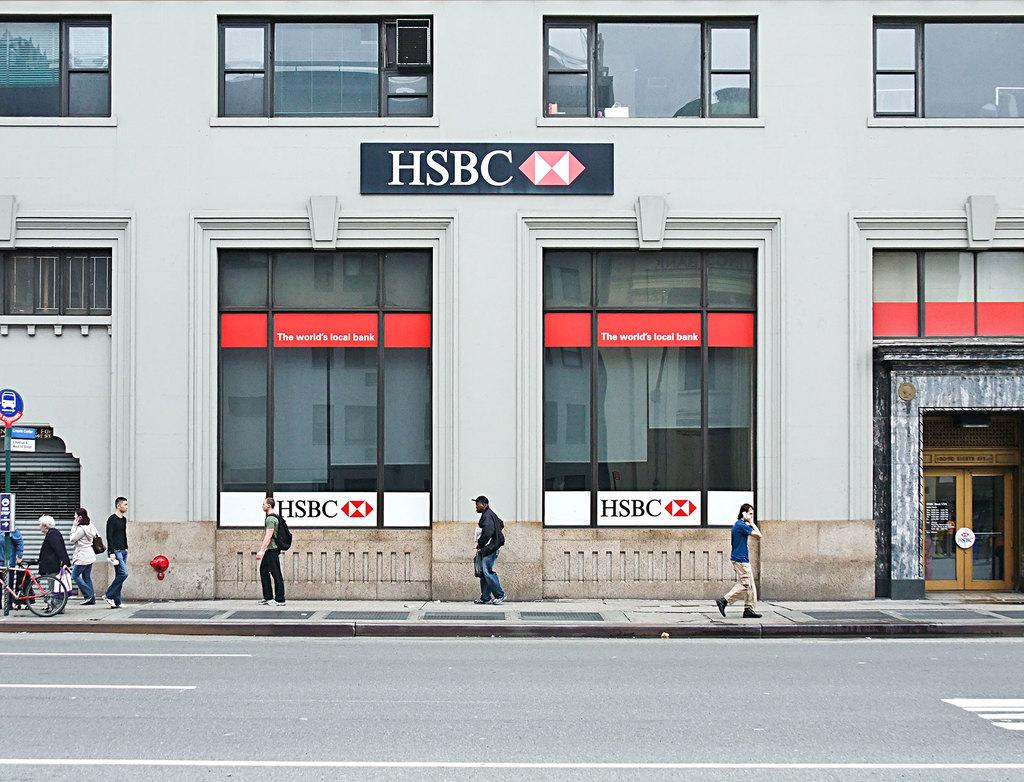<image>
Present a compact description of the photo's key features. People walking in front of the building with HSBC below the top windows. 